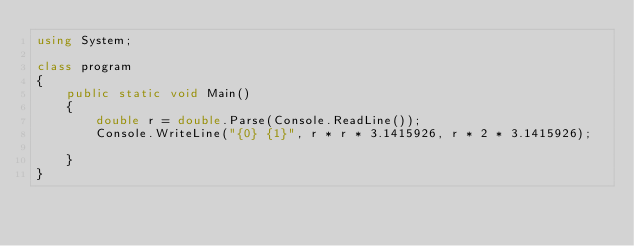<code> <loc_0><loc_0><loc_500><loc_500><_C#_>using System;

class program
{
    public static void Main()
    {
        double r = double.Parse(Console.ReadLine());
        Console.WriteLine("{0} {1}", r * r * 3.1415926, r * 2 * 3.1415926);

    }
}</code> 